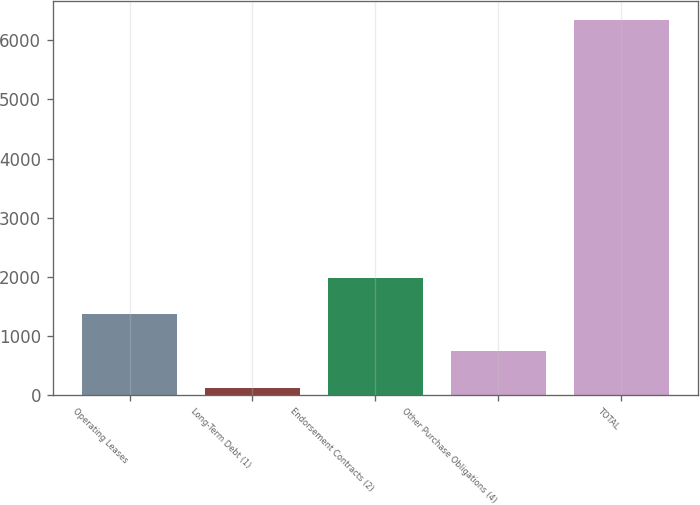Convert chart. <chart><loc_0><loc_0><loc_500><loc_500><bar_chart><fcel>Operating Leases<fcel>Long-Term Debt (1)<fcel>Endorsement Contracts (2)<fcel>Other Purchase Obligations (4)<fcel>TOTAL<nl><fcel>1360.8<fcel>115<fcel>1983.7<fcel>737.9<fcel>6344<nl></chart> 